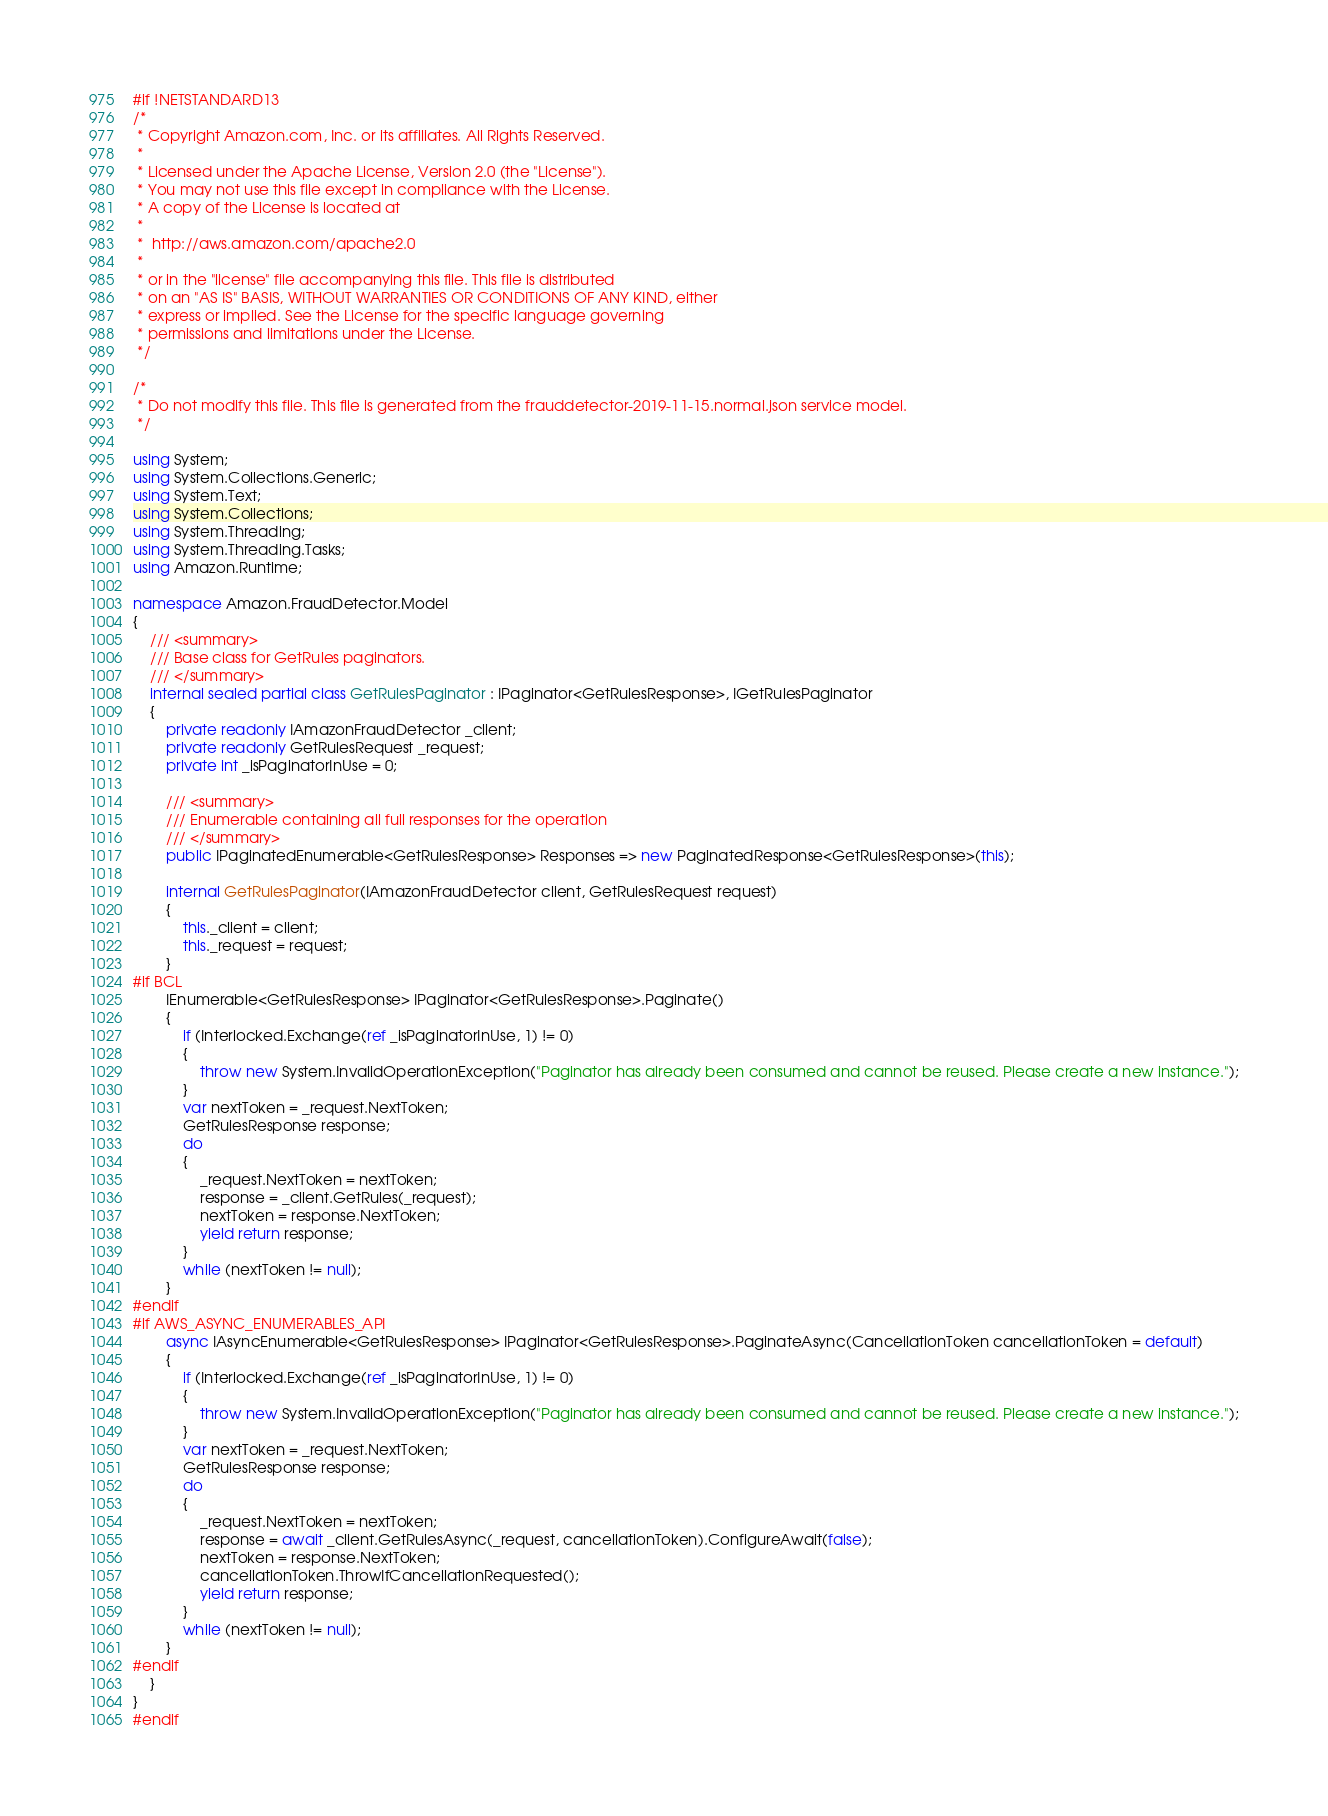Convert code to text. <code><loc_0><loc_0><loc_500><loc_500><_C#_>#if !NETSTANDARD13
/*
 * Copyright Amazon.com, Inc. or its affiliates. All Rights Reserved.
 * 
 * Licensed under the Apache License, Version 2.0 (the "License").
 * You may not use this file except in compliance with the License.
 * A copy of the License is located at
 * 
 *  http://aws.amazon.com/apache2.0
 * 
 * or in the "license" file accompanying this file. This file is distributed
 * on an "AS IS" BASIS, WITHOUT WARRANTIES OR CONDITIONS OF ANY KIND, either
 * express or implied. See the License for the specific language governing
 * permissions and limitations under the License.
 */

/*
 * Do not modify this file. This file is generated from the frauddetector-2019-11-15.normal.json service model.
 */

using System;
using System.Collections.Generic;
using System.Text;
using System.Collections;
using System.Threading;
using System.Threading.Tasks;
using Amazon.Runtime;
 
namespace Amazon.FraudDetector.Model
{
    /// <summary>
    /// Base class for GetRules paginators.
    /// </summary>
    internal sealed partial class GetRulesPaginator : IPaginator<GetRulesResponse>, IGetRulesPaginator
    {
        private readonly IAmazonFraudDetector _client;
        private readonly GetRulesRequest _request;
        private int _isPaginatorInUse = 0;
        
        /// <summary>
        /// Enumerable containing all full responses for the operation
        /// </summary>
        public IPaginatedEnumerable<GetRulesResponse> Responses => new PaginatedResponse<GetRulesResponse>(this);

        internal GetRulesPaginator(IAmazonFraudDetector client, GetRulesRequest request)
        {
            this._client = client;
            this._request = request;
        }
#if BCL
        IEnumerable<GetRulesResponse> IPaginator<GetRulesResponse>.Paginate()
        {
            if (Interlocked.Exchange(ref _isPaginatorInUse, 1) != 0)
            {
                throw new System.InvalidOperationException("Paginator has already been consumed and cannot be reused. Please create a new instance.");
            }
            var nextToken = _request.NextToken;
            GetRulesResponse response;
            do
            {
                _request.NextToken = nextToken;
                response = _client.GetRules(_request);
                nextToken = response.NextToken;
                yield return response;
            }
            while (nextToken != null);
        }
#endif
#if AWS_ASYNC_ENUMERABLES_API
        async IAsyncEnumerable<GetRulesResponse> IPaginator<GetRulesResponse>.PaginateAsync(CancellationToken cancellationToken = default)
        {
            if (Interlocked.Exchange(ref _isPaginatorInUse, 1) != 0)
            {
                throw new System.InvalidOperationException("Paginator has already been consumed and cannot be reused. Please create a new instance.");
            }
            var nextToken = _request.NextToken;
            GetRulesResponse response;
            do
            {
                _request.NextToken = nextToken;
                response = await _client.GetRulesAsync(_request, cancellationToken).ConfigureAwait(false);
                nextToken = response.NextToken;
                cancellationToken.ThrowIfCancellationRequested();
                yield return response;
            }
            while (nextToken != null);
        }
#endif
    }
}
#endif</code> 